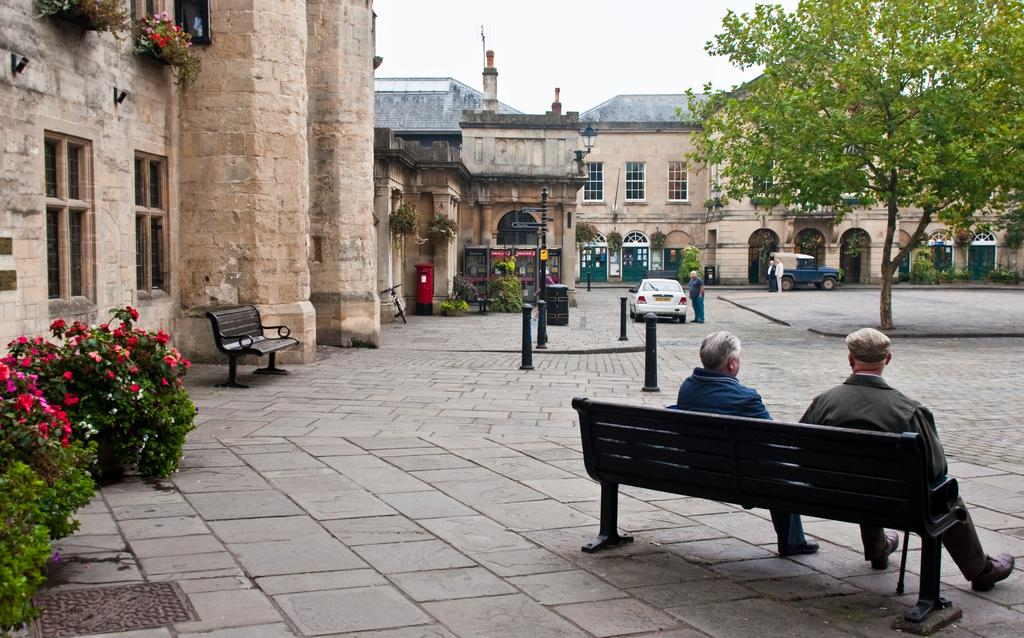How many people are sitting on the bench in the image? There are two persons sitting on a bench in the image. What type of vegetation can be seen in the image? There is a plant and flowers in the image. What type of seating is present in the image? There is a bench in the image. What type of structures are visible in the background? There are buildings in the image. What type of tree is present in the image? There is a tree in the image. What type of vehicle is present in the image? There is a car in the image. How many people are standing in the image? There are two persons standing in the image. How many light bulbs are hanging from the tree in the image? There are no light bulbs present in the image; there is a tree and flowers, but no bulbs. Can you see any sheep grazing in the background of the image? There are no sheep present in the image; the focus is on the people, bench, and surrounding vegetation and structures. 